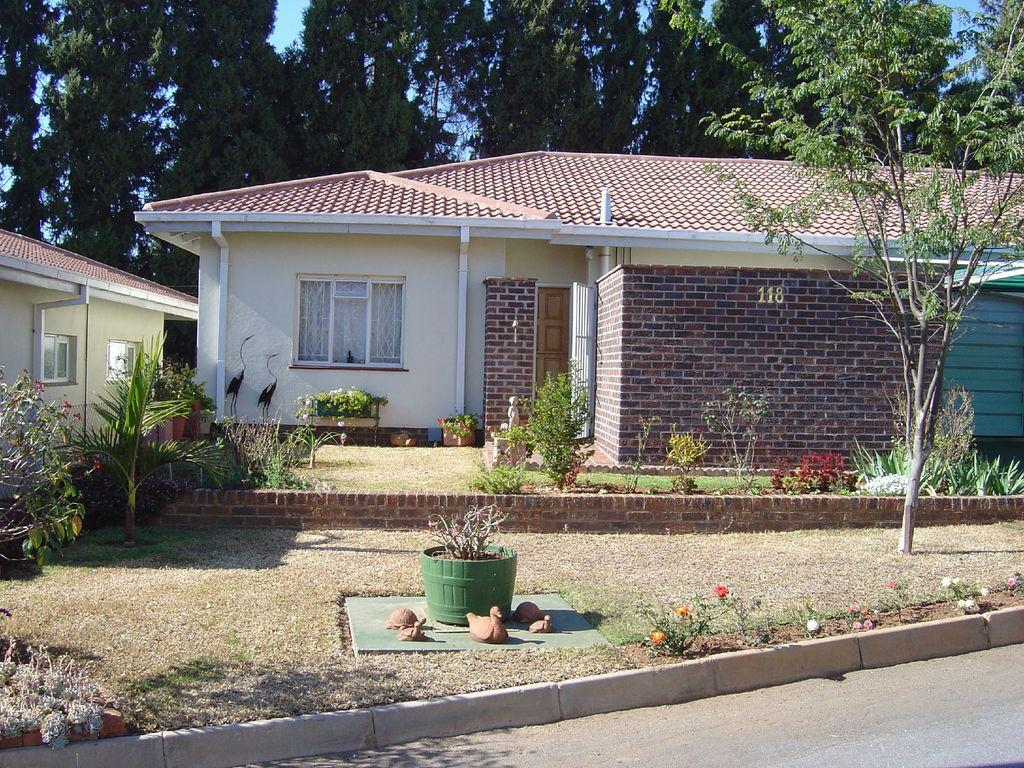What type of structures can be seen in the image? There are houses in the image. What other elements can be found in the image besides houses? There are plants, trees, toys, grass, and flower plants in the image. How many eyes can be seen on the toys in the image? There is no information about the toys having eyes in the image, and therefore we cannot determine the number of eyes. 